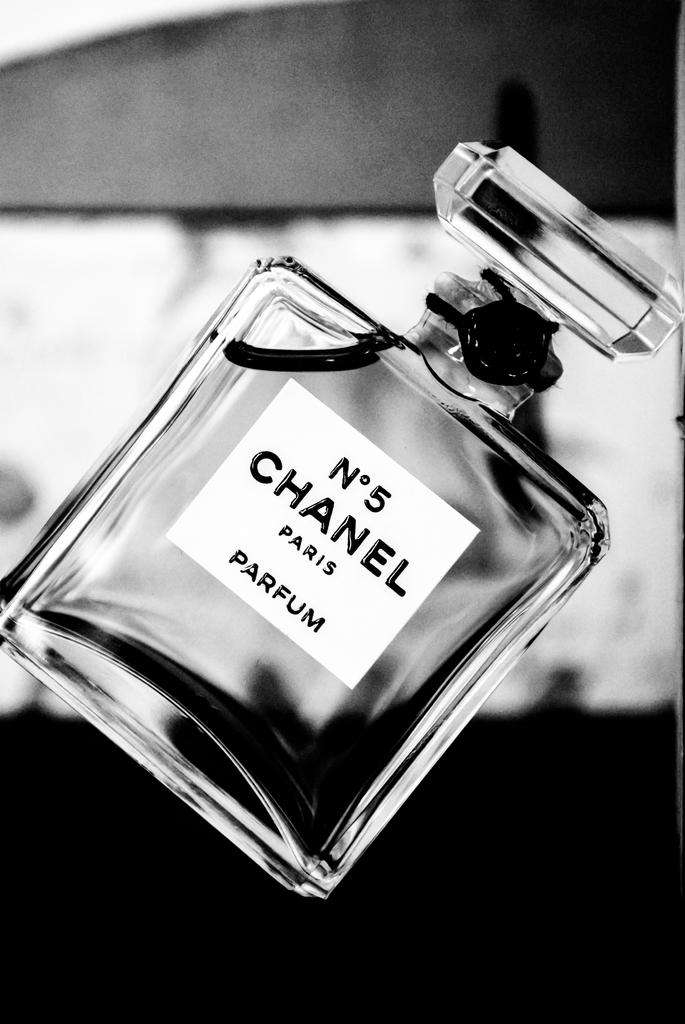<image>
Offer a succinct explanation of the picture presented. A bottle of Chanel number 5 parfum titled to the right. 